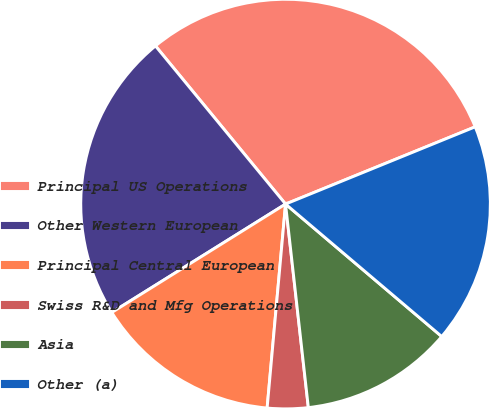<chart> <loc_0><loc_0><loc_500><loc_500><pie_chart><fcel>Principal US Operations<fcel>Other Western European<fcel>Principal Central European<fcel>Swiss R&D and Mfg Operations<fcel>Asia<fcel>Other (a)<nl><fcel>29.8%<fcel>22.92%<fcel>14.69%<fcel>3.21%<fcel>12.03%<fcel>17.35%<nl></chart> 